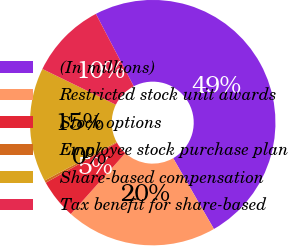Convert chart. <chart><loc_0><loc_0><loc_500><loc_500><pie_chart><fcel>(In millions)<fcel>Restricted stock unit awards<fcel>Stock options<fcel>Employee stock purchase plan<fcel>Share-based compensation<fcel>Tax benefit for share-based<nl><fcel>49.36%<fcel>19.94%<fcel>5.22%<fcel>0.32%<fcel>15.03%<fcel>10.13%<nl></chart> 